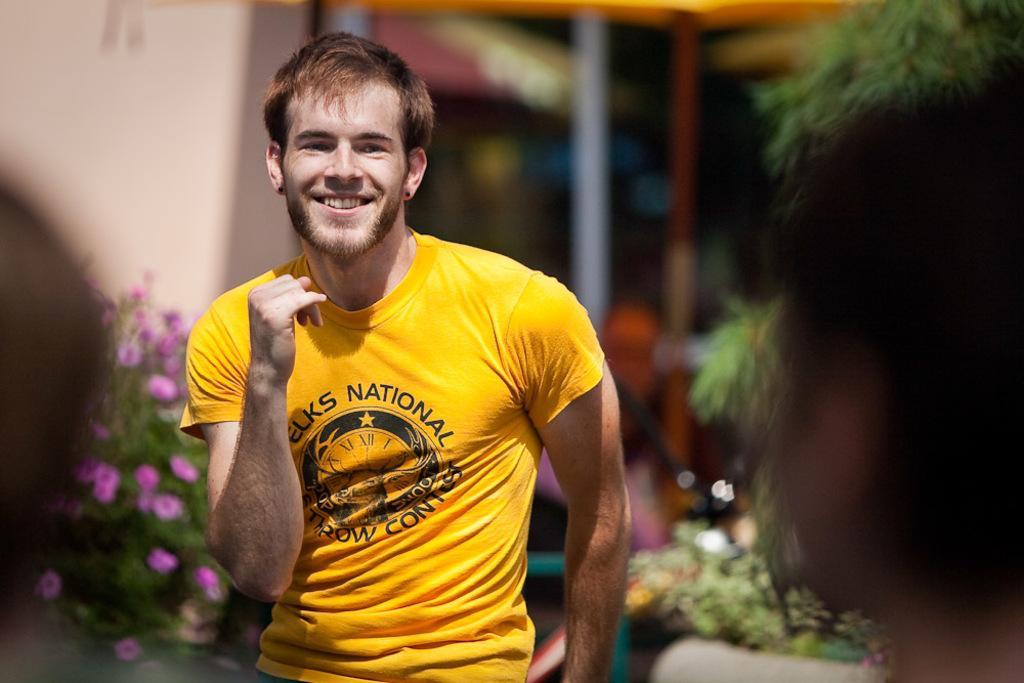Please provide a concise description of this image. In the middle of the image a man is standing and smiling. Behind him there are some plants and flowers. Top left side of the image there is a wall. Top right side of the image there is a tree. Bottom of the image few persons are standing. 